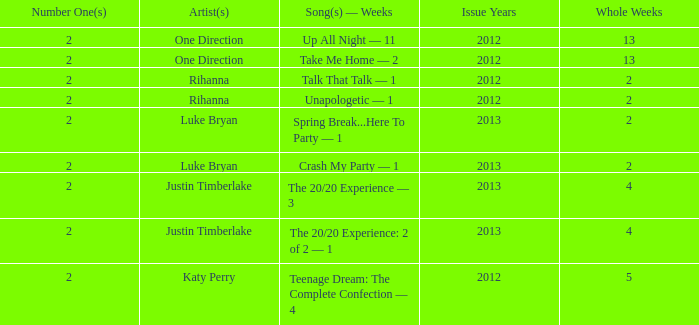What is the longest number of weeks any 1 song was at number #1? 13.0. 